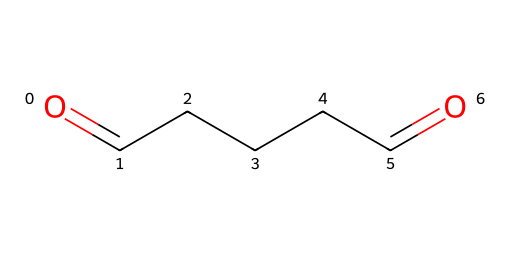What is the molecular formula of glutaraldehyde? The SMILES representation, O=CCCCC=O, indicates there are five carbon atoms, and the two terminal carbon atoms are each double-bonded to an oxygen atom. Thus, we can deduce that the molecular formula is C5H8O2, which accounts for all the atoms present.
Answer: C5H8O2 How many carbon atoms are present in glutaraldehyde? Counting the number of 'C' symbols in the SMILES representation, we see there are five 'C' present, which means there are five carbon atoms in the molecule.
Answer: 5 What type of functional group is present in glutaraldehyde? The presence of the terminal carbonyl groups (C=O) at both ends of the molecule indicates it has aldehyde functional groups, as aldehydes are characterized by at least one carbonyl group at the end of a carbon chain.
Answer: aldehyde What is the total number of hydrogen atoms in glutaraldehyde? The SMILES representation indicates five carbon atoms, and with the two hydrogens attached to the central carbon atoms, and the end carbon atoms already being double bonded to oxygens, we can derive that the total number of hydrogen atoms is 8.
Answer: 8 Is glutaraldehyde a saturated or unsaturated compound? The structure shows double bonds (C=O) present at the terminal ends and thus indicates unsaturation in the carbon chain. Compounds like glutaraldehyde that contain double bonds are classified as unsaturated.
Answer: unsaturated 